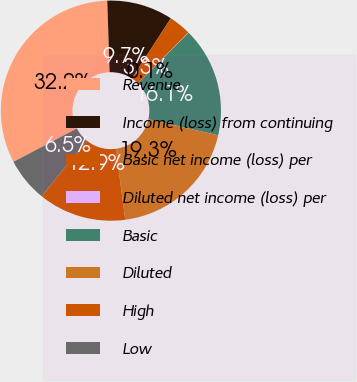Convert chart to OTSL. <chart><loc_0><loc_0><loc_500><loc_500><pie_chart><fcel>Revenue<fcel>Income (loss) from continuing<fcel>Basic net income (loss) per<fcel>Diluted net income (loss) per<fcel>Basic<fcel>Diluted<fcel>High<fcel>Low<nl><fcel>32.17%<fcel>9.69%<fcel>3.27%<fcel>0.05%<fcel>16.11%<fcel>19.33%<fcel>12.9%<fcel>6.48%<nl></chart> 